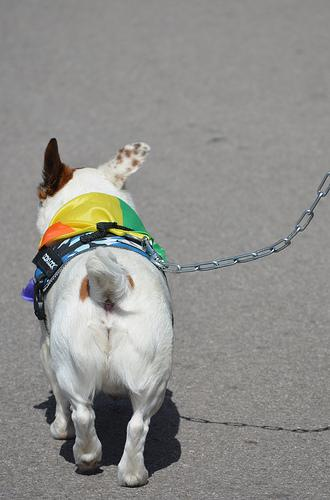Question: why does the dog have a leash?
Choices:
A. To control him.
B. To contain him.
C. To walk him.
D. To decorate him.
Answer with the letter. Answer: C Question: what color is the leash?
Choices:
A. Red.
B. Blue.
C. White.
D. Silver.
Answer with the letter. Answer: D Question: what color is the dog?
Choices:
A. White.
B. Tan.
C. Black.
D. Brown.
Answer with the letter. Answer: A Question: how many ears does the dog have?
Choices:
A. 1.
B. 0.
C. 2.
D. 3.
Answer with the letter. Answer: C 